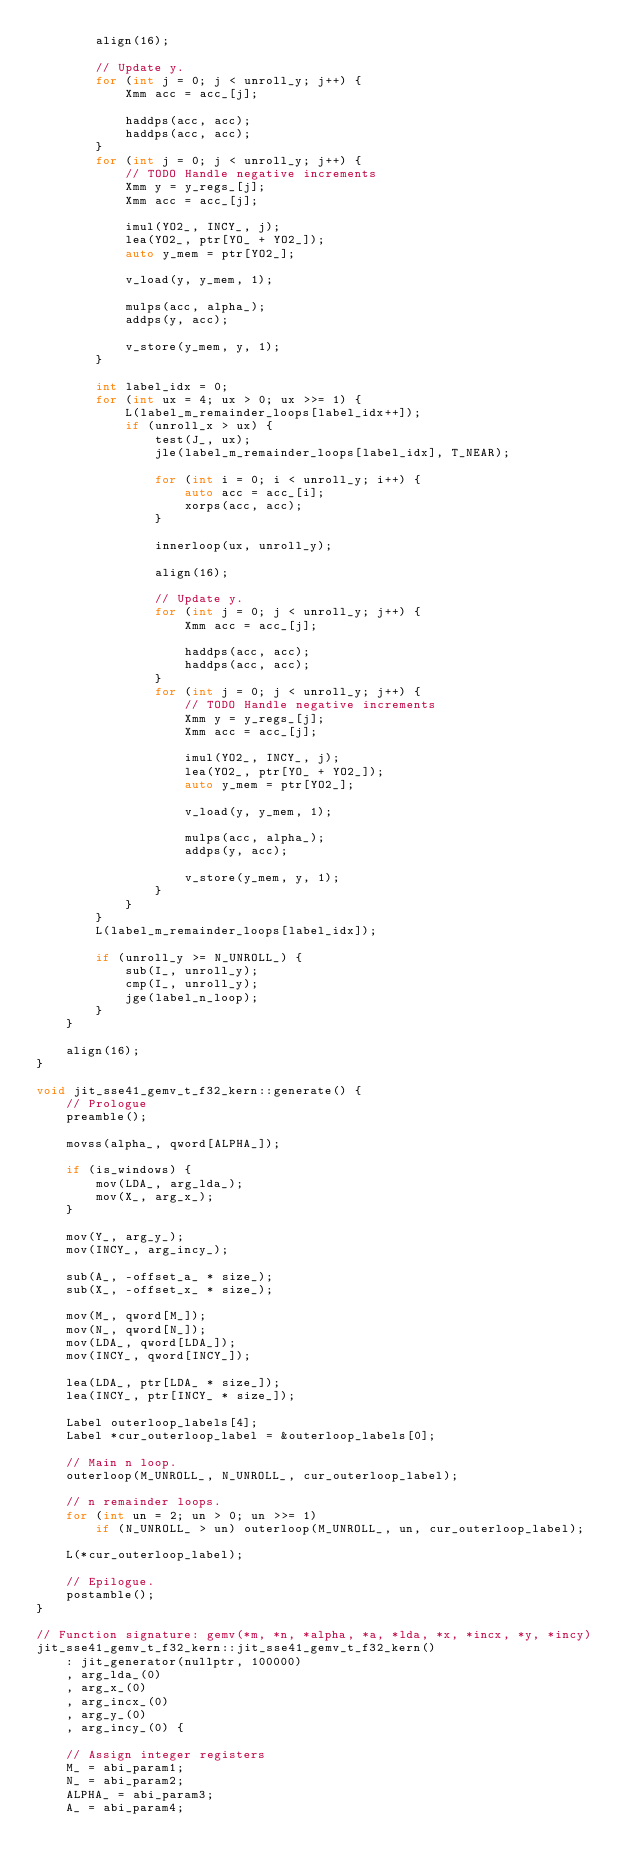<code> <loc_0><loc_0><loc_500><loc_500><_C++_>        align(16);

        // Update y.
        for (int j = 0; j < unroll_y; j++) {
            Xmm acc = acc_[j];

            haddps(acc, acc);
            haddps(acc, acc);
        }
        for (int j = 0; j < unroll_y; j++) {
            // TODO Handle negative increments
            Xmm y = y_regs_[j];
            Xmm acc = acc_[j];

            imul(YO2_, INCY_, j);
            lea(YO2_, ptr[YO_ + YO2_]);
            auto y_mem = ptr[YO2_];

            v_load(y, y_mem, 1);

            mulps(acc, alpha_);
            addps(y, acc);

            v_store(y_mem, y, 1);
        }

        int label_idx = 0;
        for (int ux = 4; ux > 0; ux >>= 1) {
            L(label_m_remainder_loops[label_idx++]);
            if (unroll_x > ux) {
                test(J_, ux);
                jle(label_m_remainder_loops[label_idx], T_NEAR);

                for (int i = 0; i < unroll_y; i++) {
                    auto acc = acc_[i];
                    xorps(acc, acc);
                }

                innerloop(ux, unroll_y);

                align(16);

                // Update y.
                for (int j = 0; j < unroll_y; j++) {
                    Xmm acc = acc_[j];

                    haddps(acc, acc);
                    haddps(acc, acc);
                }
                for (int j = 0; j < unroll_y; j++) {
                    // TODO Handle negative increments
                    Xmm y = y_regs_[j];
                    Xmm acc = acc_[j];

                    imul(YO2_, INCY_, j);
                    lea(YO2_, ptr[YO_ + YO2_]);
                    auto y_mem = ptr[YO2_];

                    v_load(y, y_mem, 1);

                    mulps(acc, alpha_);
                    addps(y, acc);

                    v_store(y_mem, y, 1);
                }
            }
        }
        L(label_m_remainder_loops[label_idx]);

        if (unroll_y >= N_UNROLL_) {
            sub(I_, unroll_y);
            cmp(I_, unroll_y);
            jge(label_n_loop);
        }
    }

    align(16);
}

void jit_sse41_gemv_t_f32_kern::generate() {
    // Prologue
    preamble();

    movss(alpha_, qword[ALPHA_]);

    if (is_windows) {
        mov(LDA_, arg_lda_);
        mov(X_, arg_x_);
    }

    mov(Y_, arg_y_);
    mov(INCY_, arg_incy_);

    sub(A_, -offset_a_ * size_);
    sub(X_, -offset_x_ * size_);

    mov(M_, qword[M_]);
    mov(N_, qword[N_]);
    mov(LDA_, qword[LDA_]);
    mov(INCY_, qword[INCY_]);

    lea(LDA_, ptr[LDA_ * size_]);
    lea(INCY_, ptr[INCY_ * size_]);

    Label outerloop_labels[4];
    Label *cur_outerloop_label = &outerloop_labels[0];

    // Main n loop.
    outerloop(M_UNROLL_, N_UNROLL_, cur_outerloop_label);

    // n remainder loops.
    for (int un = 2; un > 0; un >>= 1)
        if (N_UNROLL_ > un) outerloop(M_UNROLL_, un, cur_outerloop_label);

    L(*cur_outerloop_label);

    // Epilogue.
    postamble();
}

// Function signature: gemv(*m, *n, *alpha, *a, *lda, *x, *incx, *y, *incy)
jit_sse41_gemv_t_f32_kern::jit_sse41_gemv_t_f32_kern()
    : jit_generator(nullptr, 100000)
    , arg_lda_(0)
    , arg_x_(0)
    , arg_incx_(0)
    , arg_y_(0)
    , arg_incy_(0) {

    // Assign integer registers
    M_ = abi_param1;
    N_ = abi_param2;
    ALPHA_ = abi_param3;
    A_ = abi_param4;</code> 